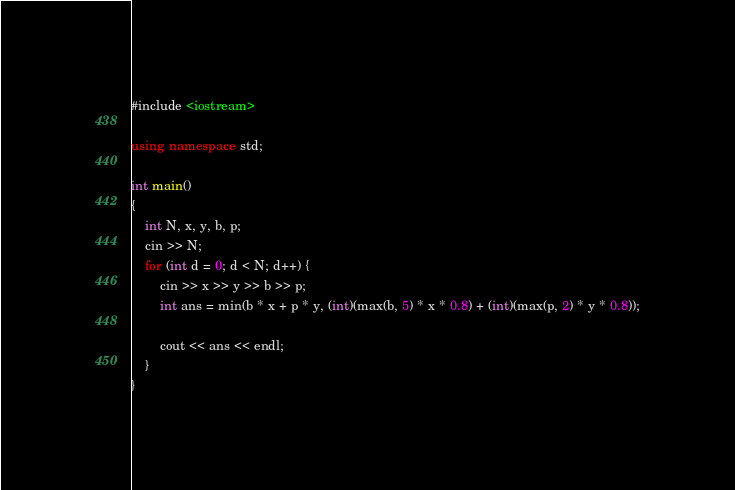<code> <loc_0><loc_0><loc_500><loc_500><_C++_>#include <iostream>

using namespace std;

int main()
{
    int N, x, y, b, p;
    cin >> N;
    for (int d = 0; d < N; d++) {
        cin >> x >> y >> b >> p;
        int ans = min(b * x + p * y, (int)(max(b, 5) * x * 0.8) + (int)(max(p, 2) * y * 0.8));

        cout << ans << endl;
    }
}</code> 